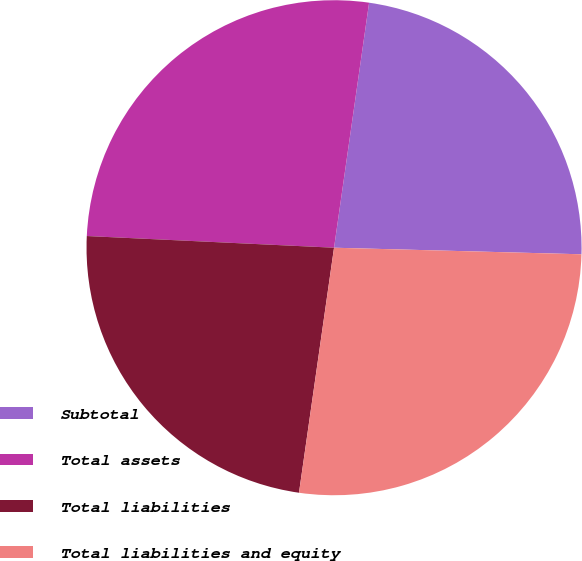Convert chart to OTSL. <chart><loc_0><loc_0><loc_500><loc_500><pie_chart><fcel>Subtotal<fcel>Total assets<fcel>Total liabilities<fcel>Total liabilities and equity<nl><fcel>23.16%<fcel>26.51%<fcel>23.49%<fcel>26.84%<nl></chart> 